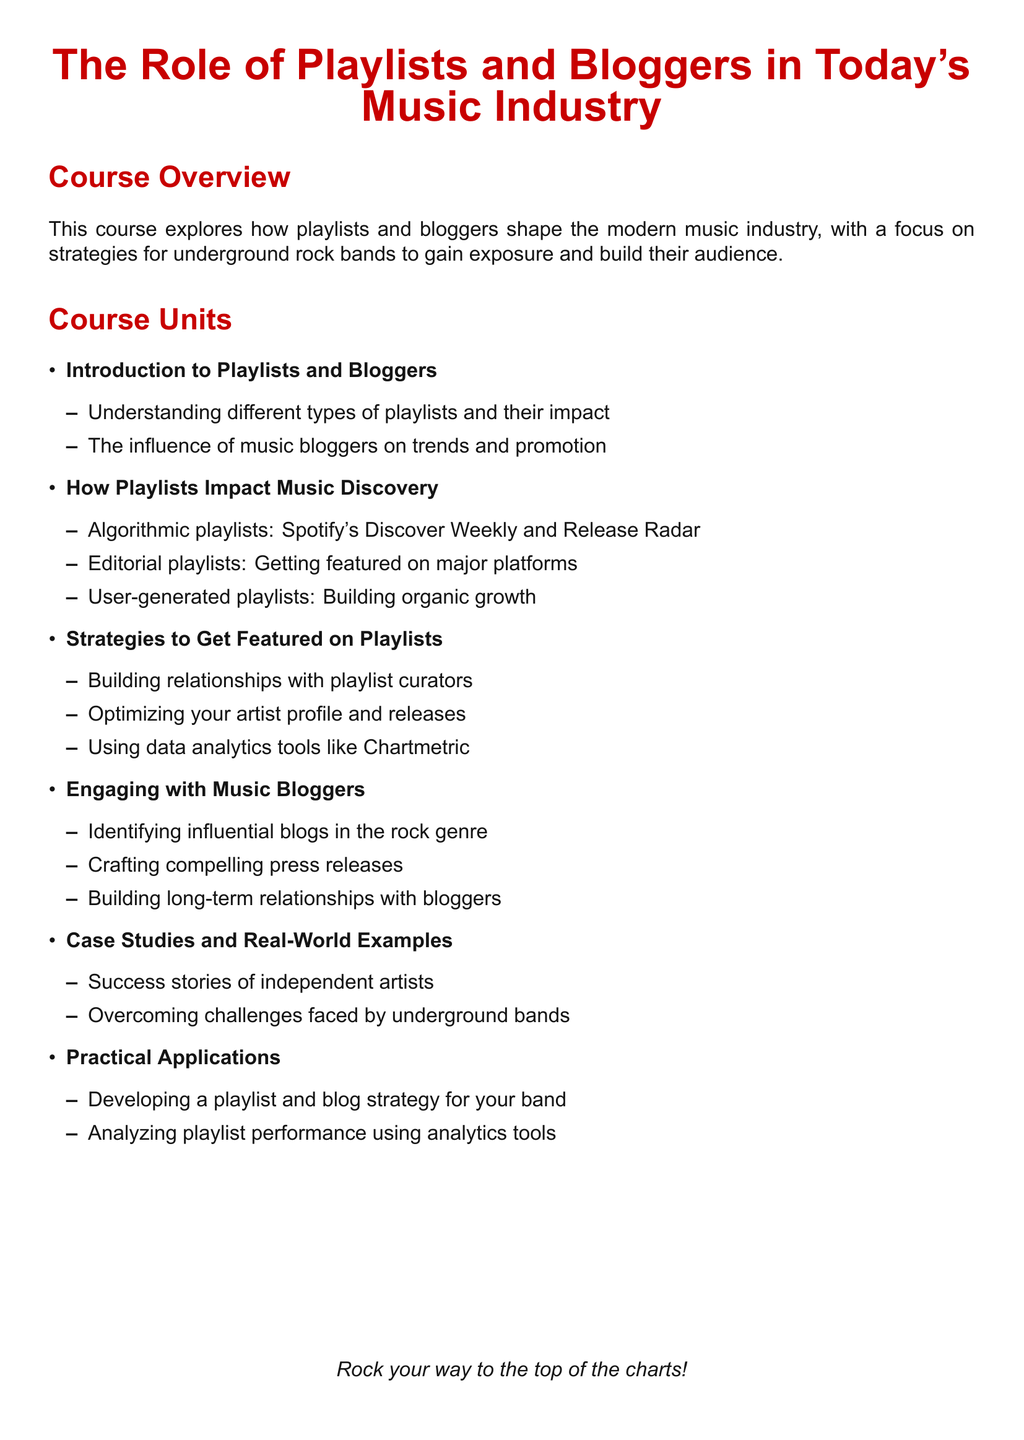What is the main focus of the course? The main focus of the course is on strategies for underground rock bands to gain exposure and build their audience through playlists and bloggers.
Answer: Strategies for underground rock bands What is a type of playlist discussed in the course? The course describes algorithmic playlists as one type of playlist affecting music discovery.
Answer: Algorithmic playlists What tool is mentioned for using data analytics? The syllabus indicates Chartmetric as a data analytics tool for understanding playlists.
Answer: Chartmetric Which genre do the influential blogs pertain to? The influential blogs relevant for engagement focus on the rock genre.
Answer: Rock genre How many main units are listed in the syllabus? The syllabus lists five main units covering different aspects of the course content.
Answer: Five What is a strategy for getting featured on playlists? One strategy mentioned is building relationships with playlist curators.
Answer: Building relationships with playlist curators What type of email communication is emphasized for engaging bloggers? Crafting compelling press releases is emphasized for reaching out to music bloggers.
Answer: Compelling press releases What is included in the practical applications unit? The practical applications unit includes developing a playlist and blog strategy for your band.
Answer: Developing a playlist and blog strategy for your band What is the course's attitude towards independent artists? The syllabus refers to success stories of independent artists, indicating a positive attitude towards them.
Answer: Success stories of independent artists 